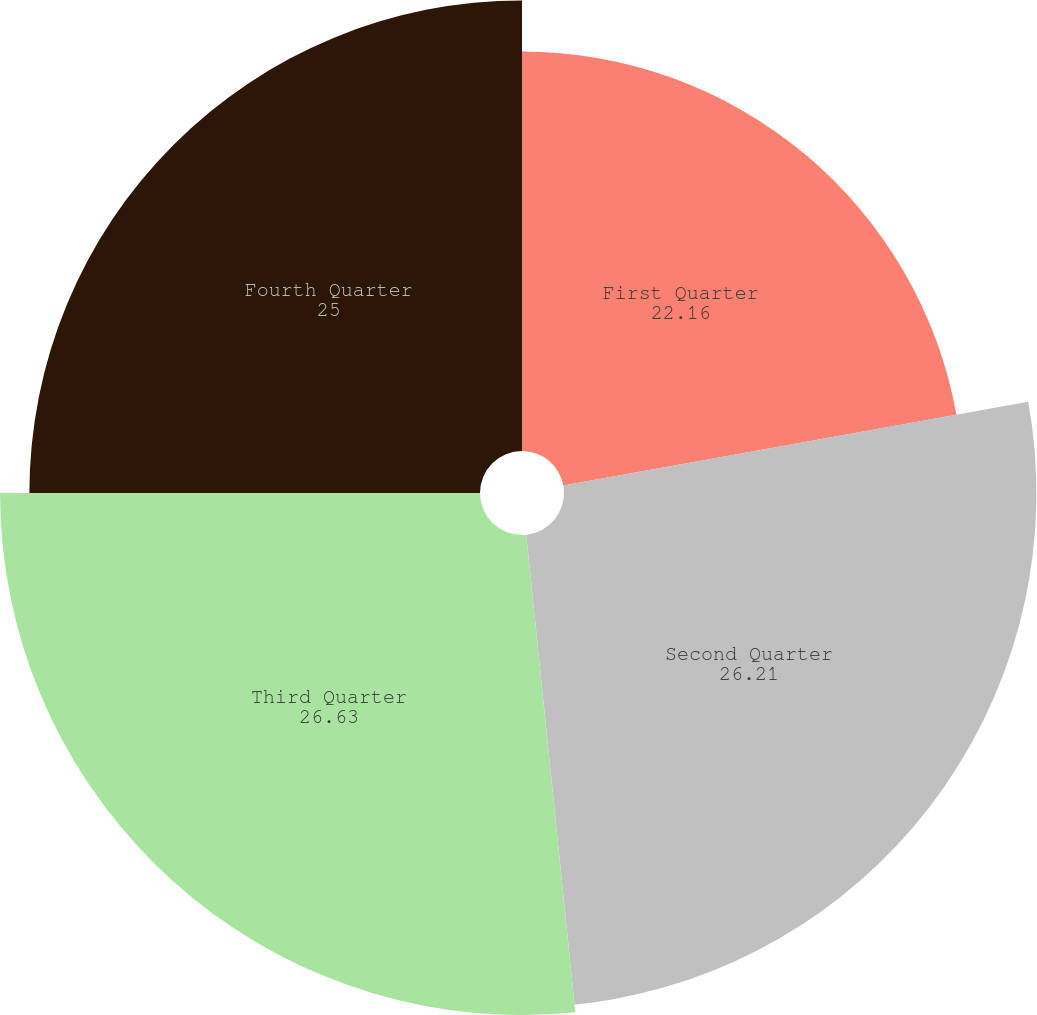<chart> <loc_0><loc_0><loc_500><loc_500><pie_chart><fcel>First Quarter<fcel>Second Quarter<fcel>Third Quarter<fcel>Fourth Quarter<nl><fcel>22.16%<fcel>26.21%<fcel>26.63%<fcel>25.0%<nl></chart> 